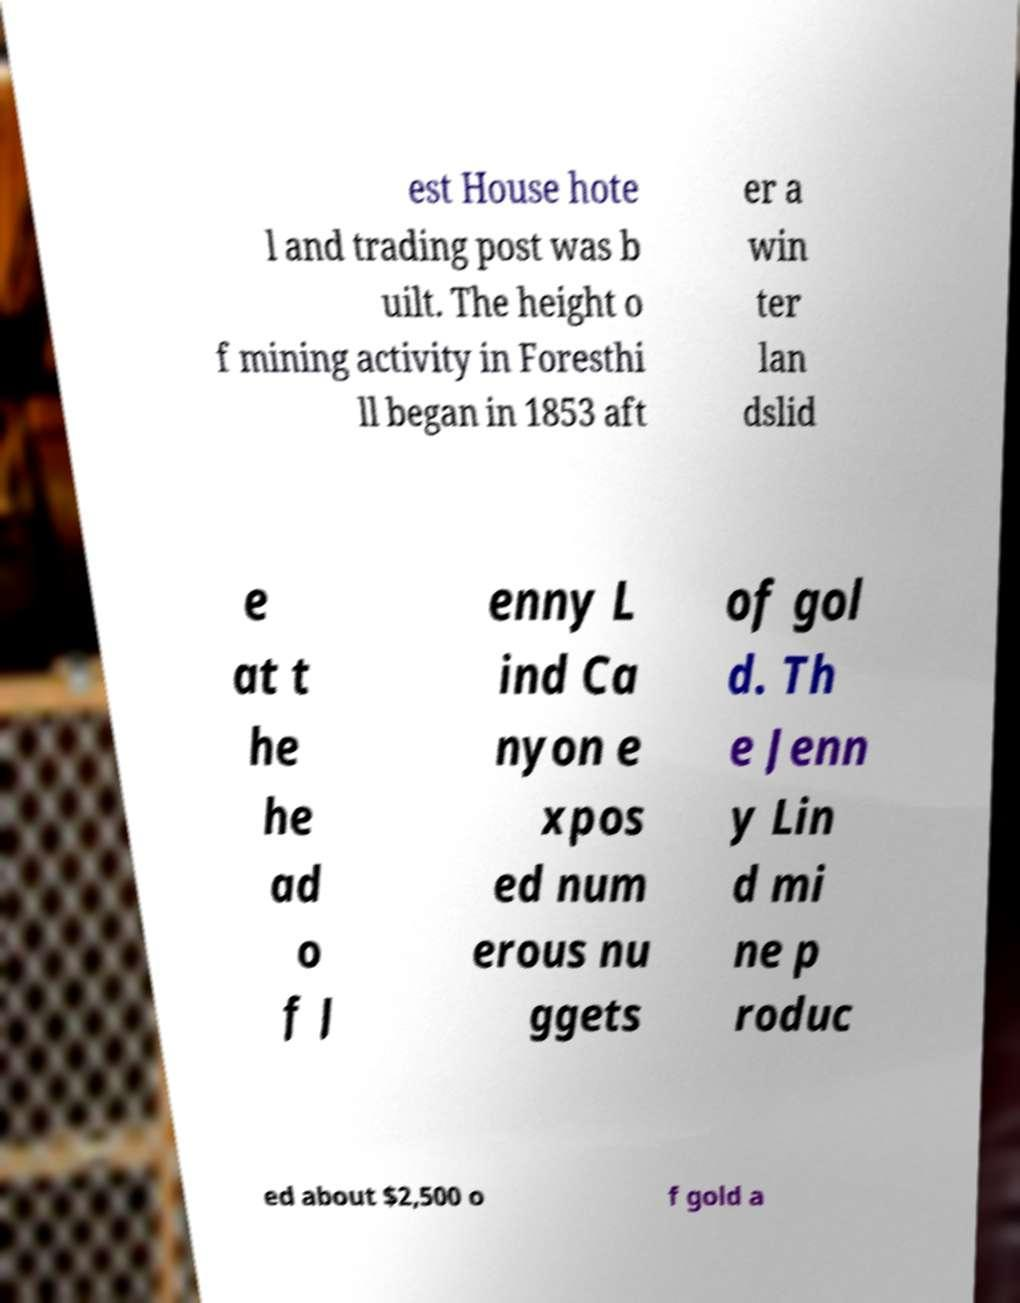Could you assist in decoding the text presented in this image and type it out clearly? est House hote l and trading post was b uilt. The height o f mining activity in Foresthi ll began in 1853 aft er a win ter lan dslid e at t he he ad o f J enny L ind Ca nyon e xpos ed num erous nu ggets of gol d. Th e Jenn y Lin d mi ne p roduc ed about $2,500 o f gold a 